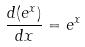Convert formula to latex. <formula><loc_0><loc_0><loc_500><loc_500>\frac { d ( e ^ { x } ) } { d x } = e ^ { x }</formula> 